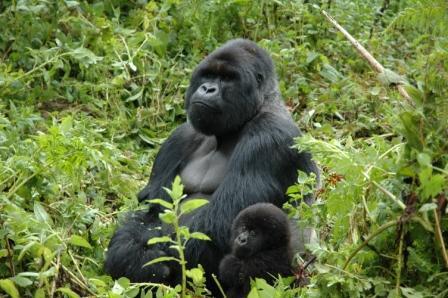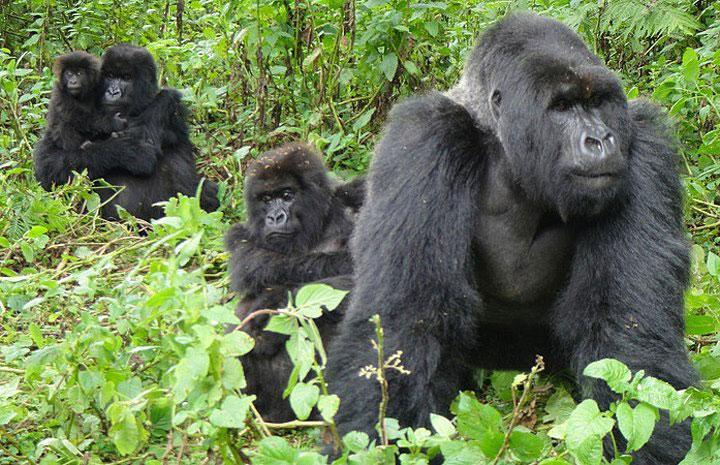The first image is the image on the left, the second image is the image on the right. For the images shown, is this caption "Each image includes a baby gorilla close to an adult gorilla who is facing leftward." true? Answer yes or no. Yes. 